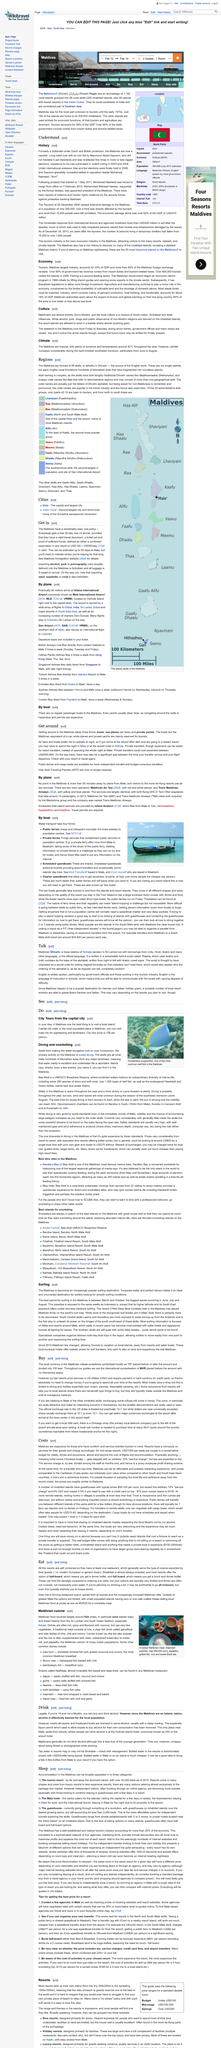Outline some significant characteristics in this image. The Maldives rufiyaa is symbolized locally as Rf... It is expected that tips be given in addition to the 10% "service charge" at the restaurant. The service charge is a common practice in Zanzibar, where hotels often impose an arbitrary 10% charge on various items, including hotel rooms booked locally. The Maldives is predominantly a Sunni Muslim country. The economic damage caused by the tsunami in 2004 was approximately 470 million USD. 